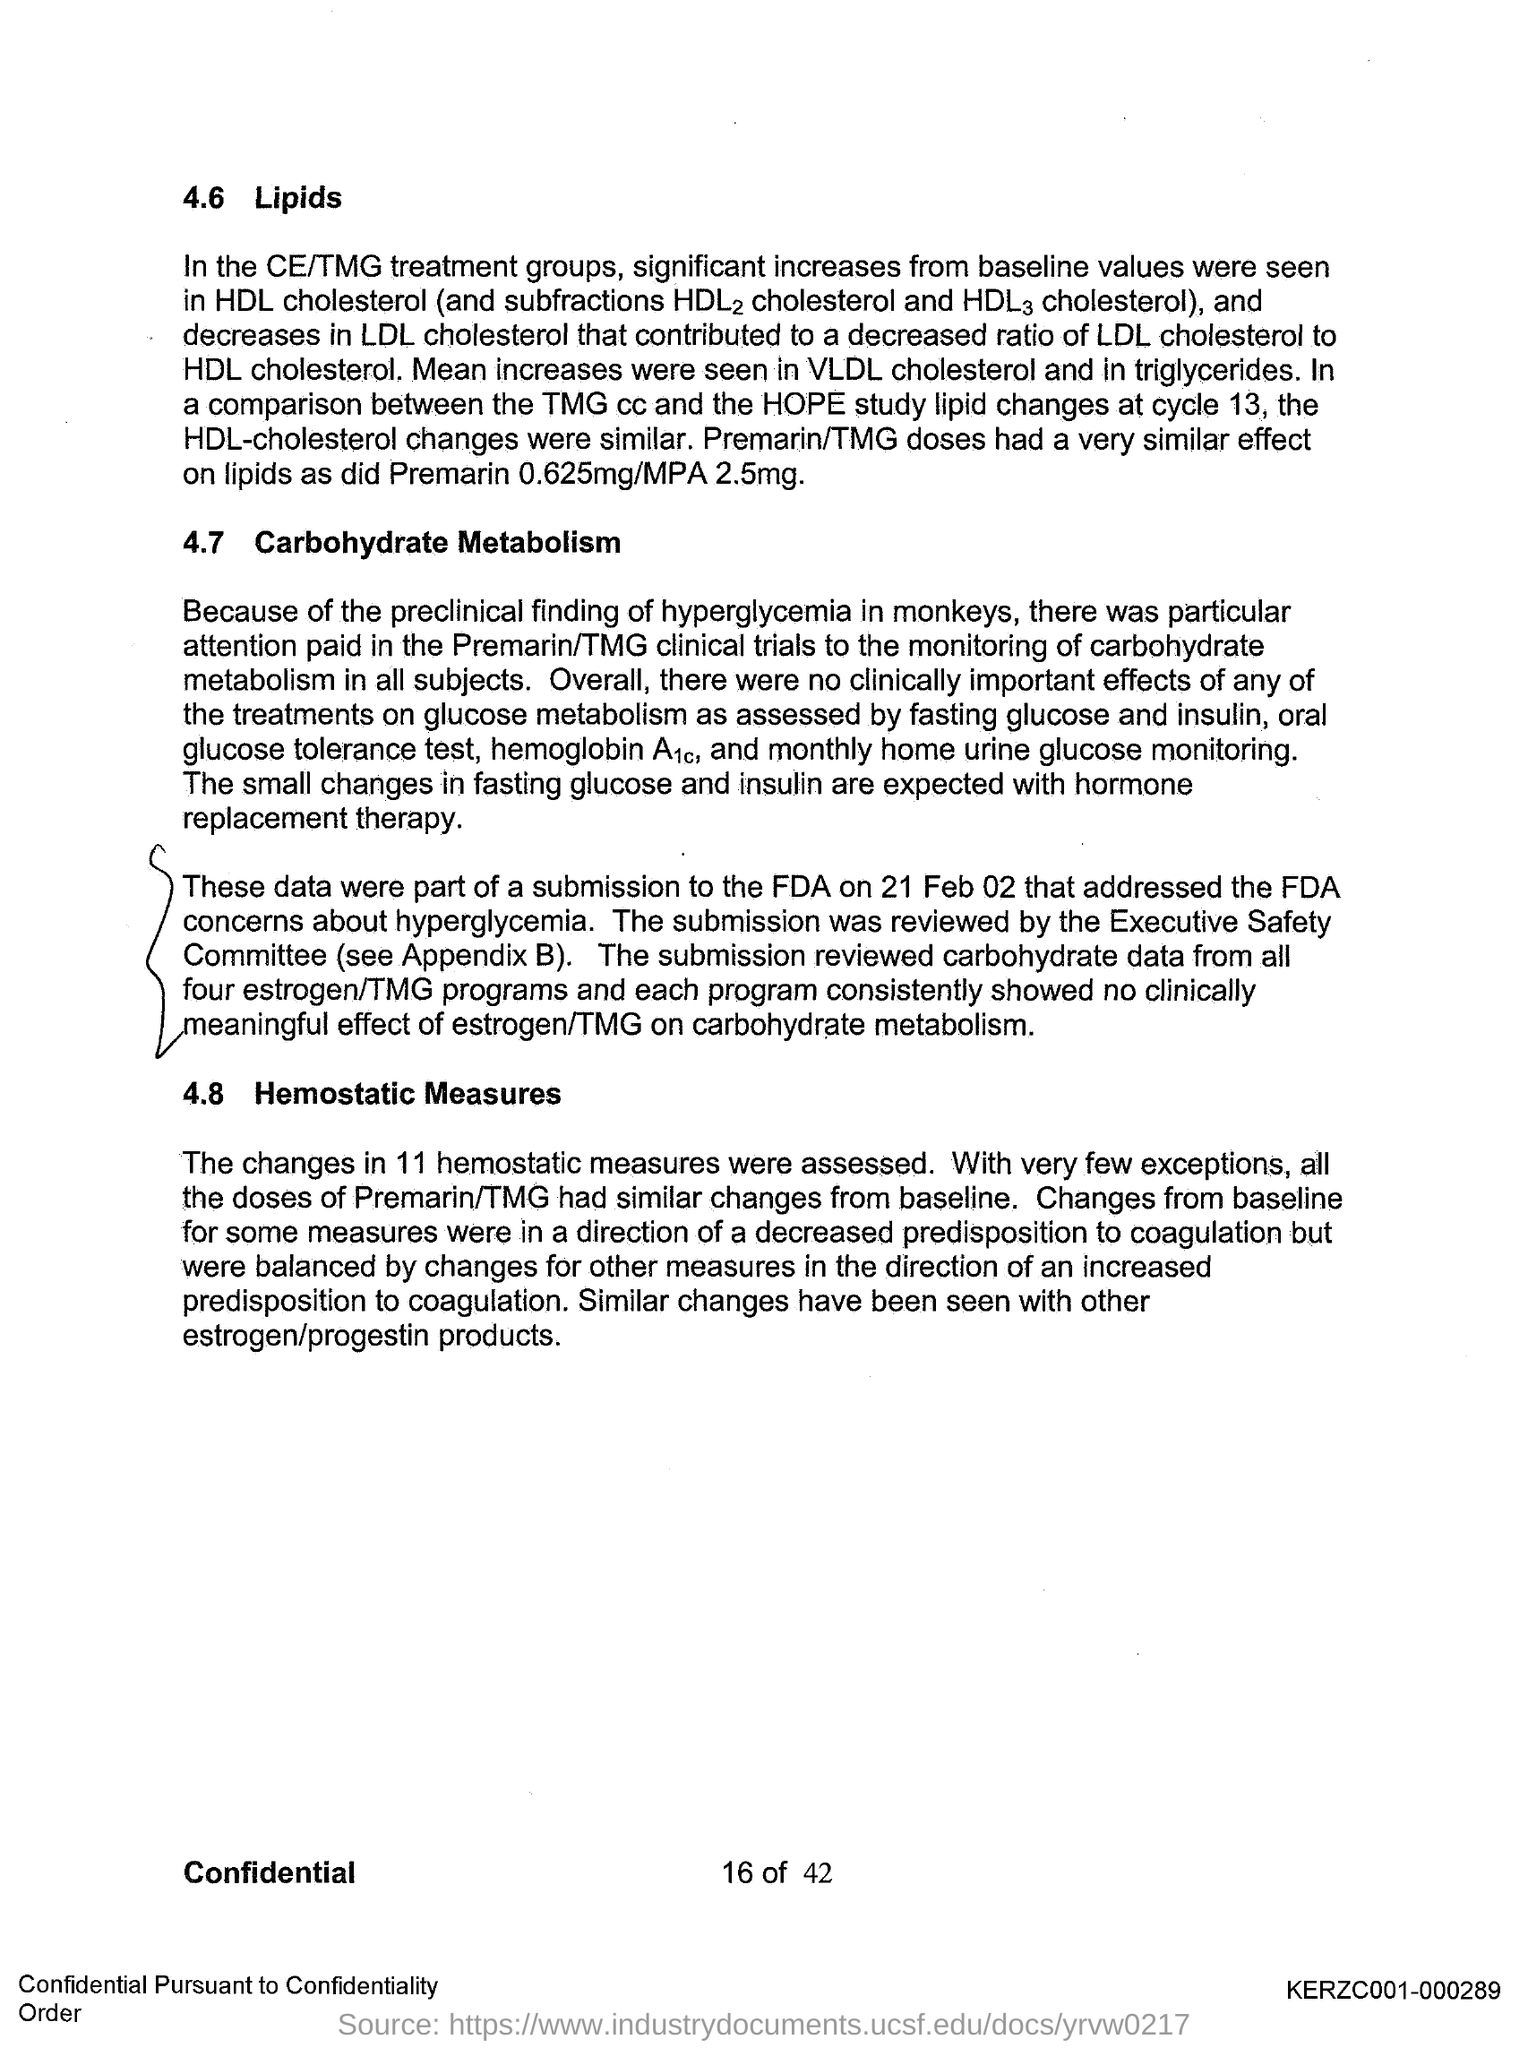What is the first title in the document?
Offer a very short reply. Lipids. What is the second title in this document?
Your answer should be compact. Carbohydrate metabolism. 